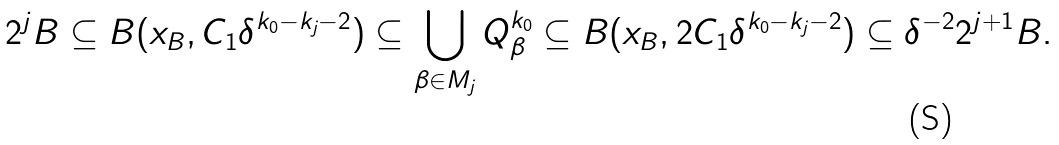Convert formula to latex. <formula><loc_0><loc_0><loc_500><loc_500>2 ^ { j } B \subseteq B ( x _ { B } , C _ { 1 } \delta ^ { k _ { 0 } - k _ { j } - 2 } ) \subseteq \bigcup _ { \beta \in M _ { j } } Q _ { \beta } ^ { k _ { 0 } } \subseteq B ( x _ { B } , 2 C _ { 1 } \delta ^ { k _ { 0 } - k _ { j } - 2 } ) \subseteq \delta ^ { - 2 } 2 ^ { j + 1 } B .</formula> 